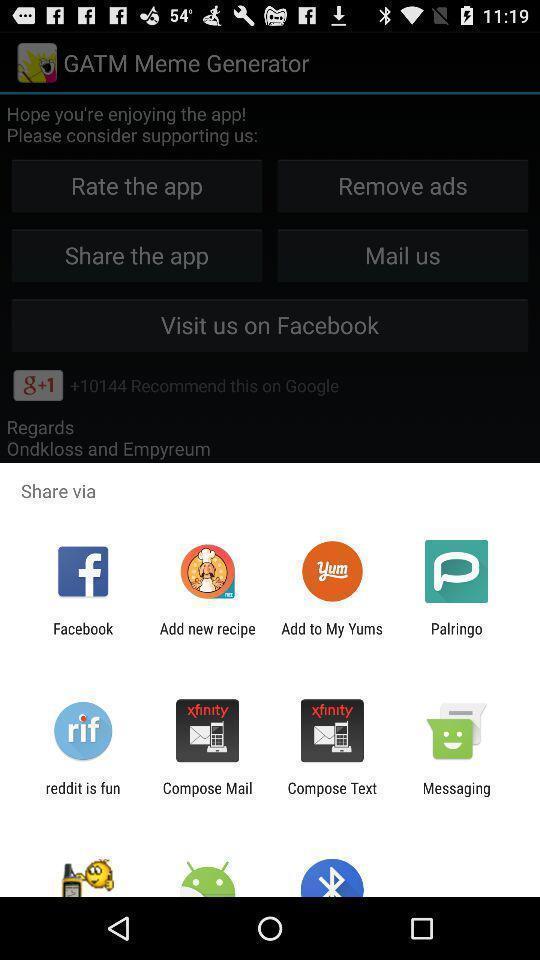Provide a detailed account of this screenshot. Screen showing multiple share options. 